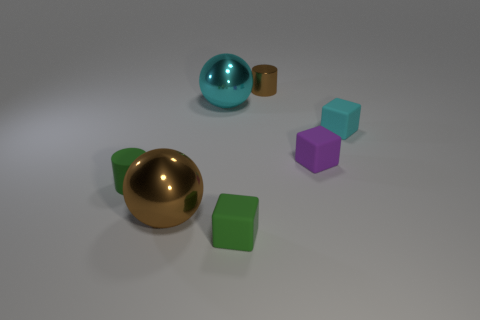Subtract all green blocks. How many blocks are left? 2 Subtract all small green cubes. How many cubes are left? 2 Subtract 2 blocks. How many blocks are left? 1 Add 3 big yellow metallic things. How many objects exist? 10 Subtract all blue cylinders. Subtract all red cubes. How many cylinders are left? 2 Subtract all yellow cubes. How many yellow cylinders are left? 0 Subtract all small objects. Subtract all small purple metal cylinders. How many objects are left? 2 Add 4 small purple matte cubes. How many small purple matte cubes are left? 5 Add 2 big blue metallic cubes. How many big blue metallic cubes exist? 2 Subtract 0 blue cubes. How many objects are left? 7 